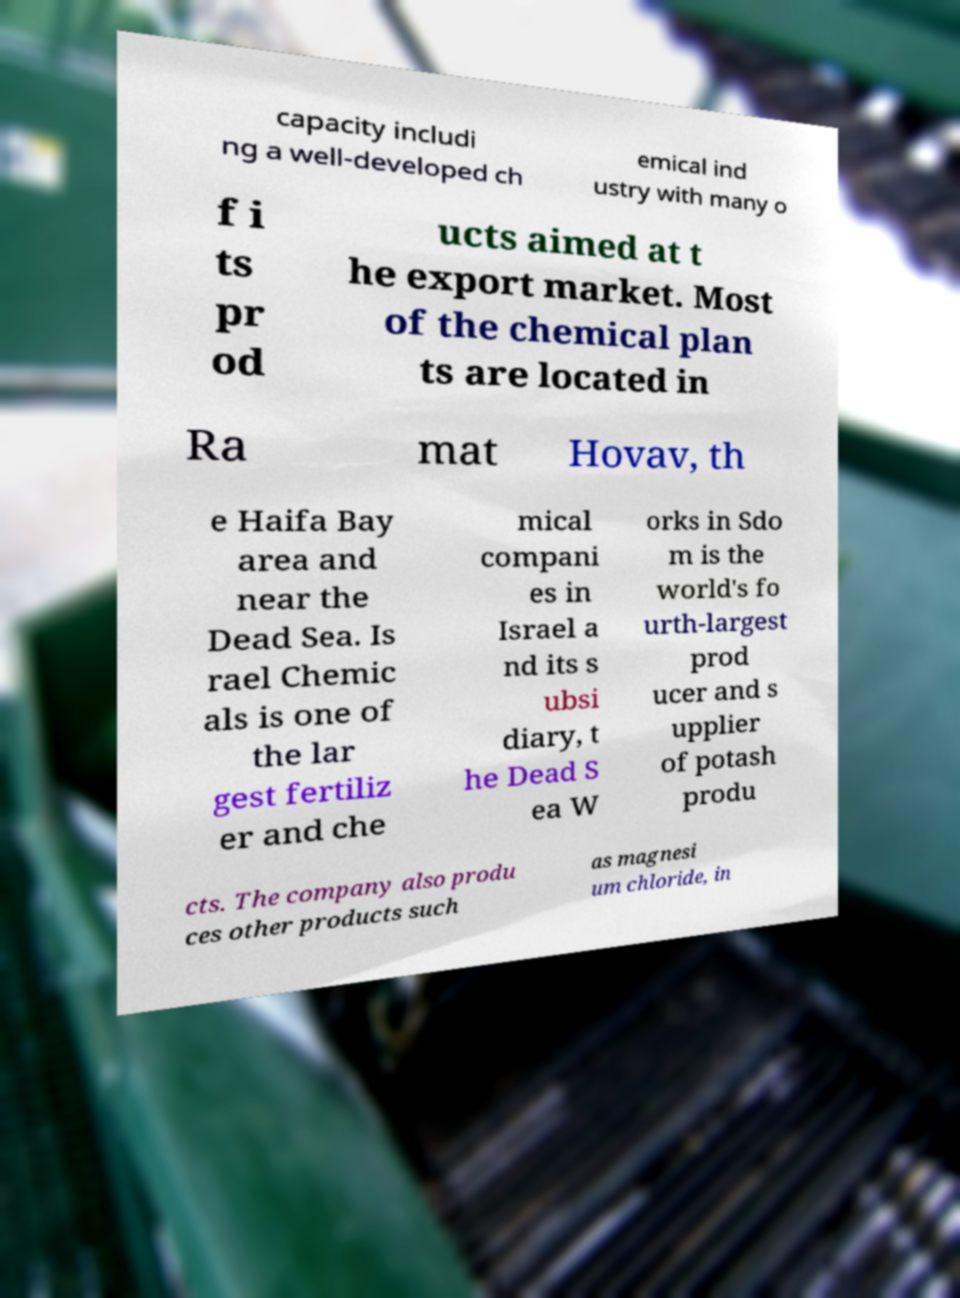I need the written content from this picture converted into text. Can you do that? capacity includi ng a well-developed ch emical ind ustry with many o f i ts pr od ucts aimed at t he export market. Most of the chemical plan ts are located in Ra mat Hovav, th e Haifa Bay area and near the Dead Sea. Is rael Chemic als is one of the lar gest fertiliz er and che mical compani es in Israel a nd its s ubsi diary, t he Dead S ea W orks in Sdo m is the world's fo urth-largest prod ucer and s upplier of potash produ cts. The company also produ ces other products such as magnesi um chloride, in 